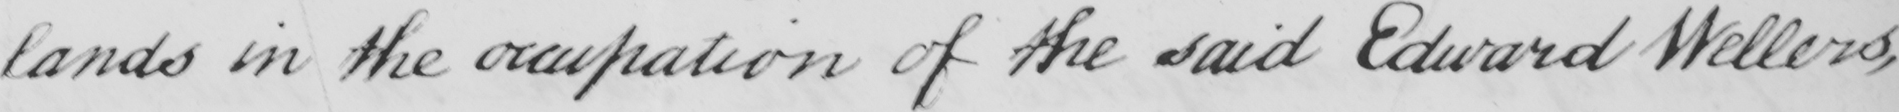Please transcribe the handwritten text in this image. lands in the occupation of the said Edward Wellers , 